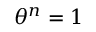Convert formula to latex. <formula><loc_0><loc_0><loc_500><loc_500>\theta ^ { n } = 1</formula> 